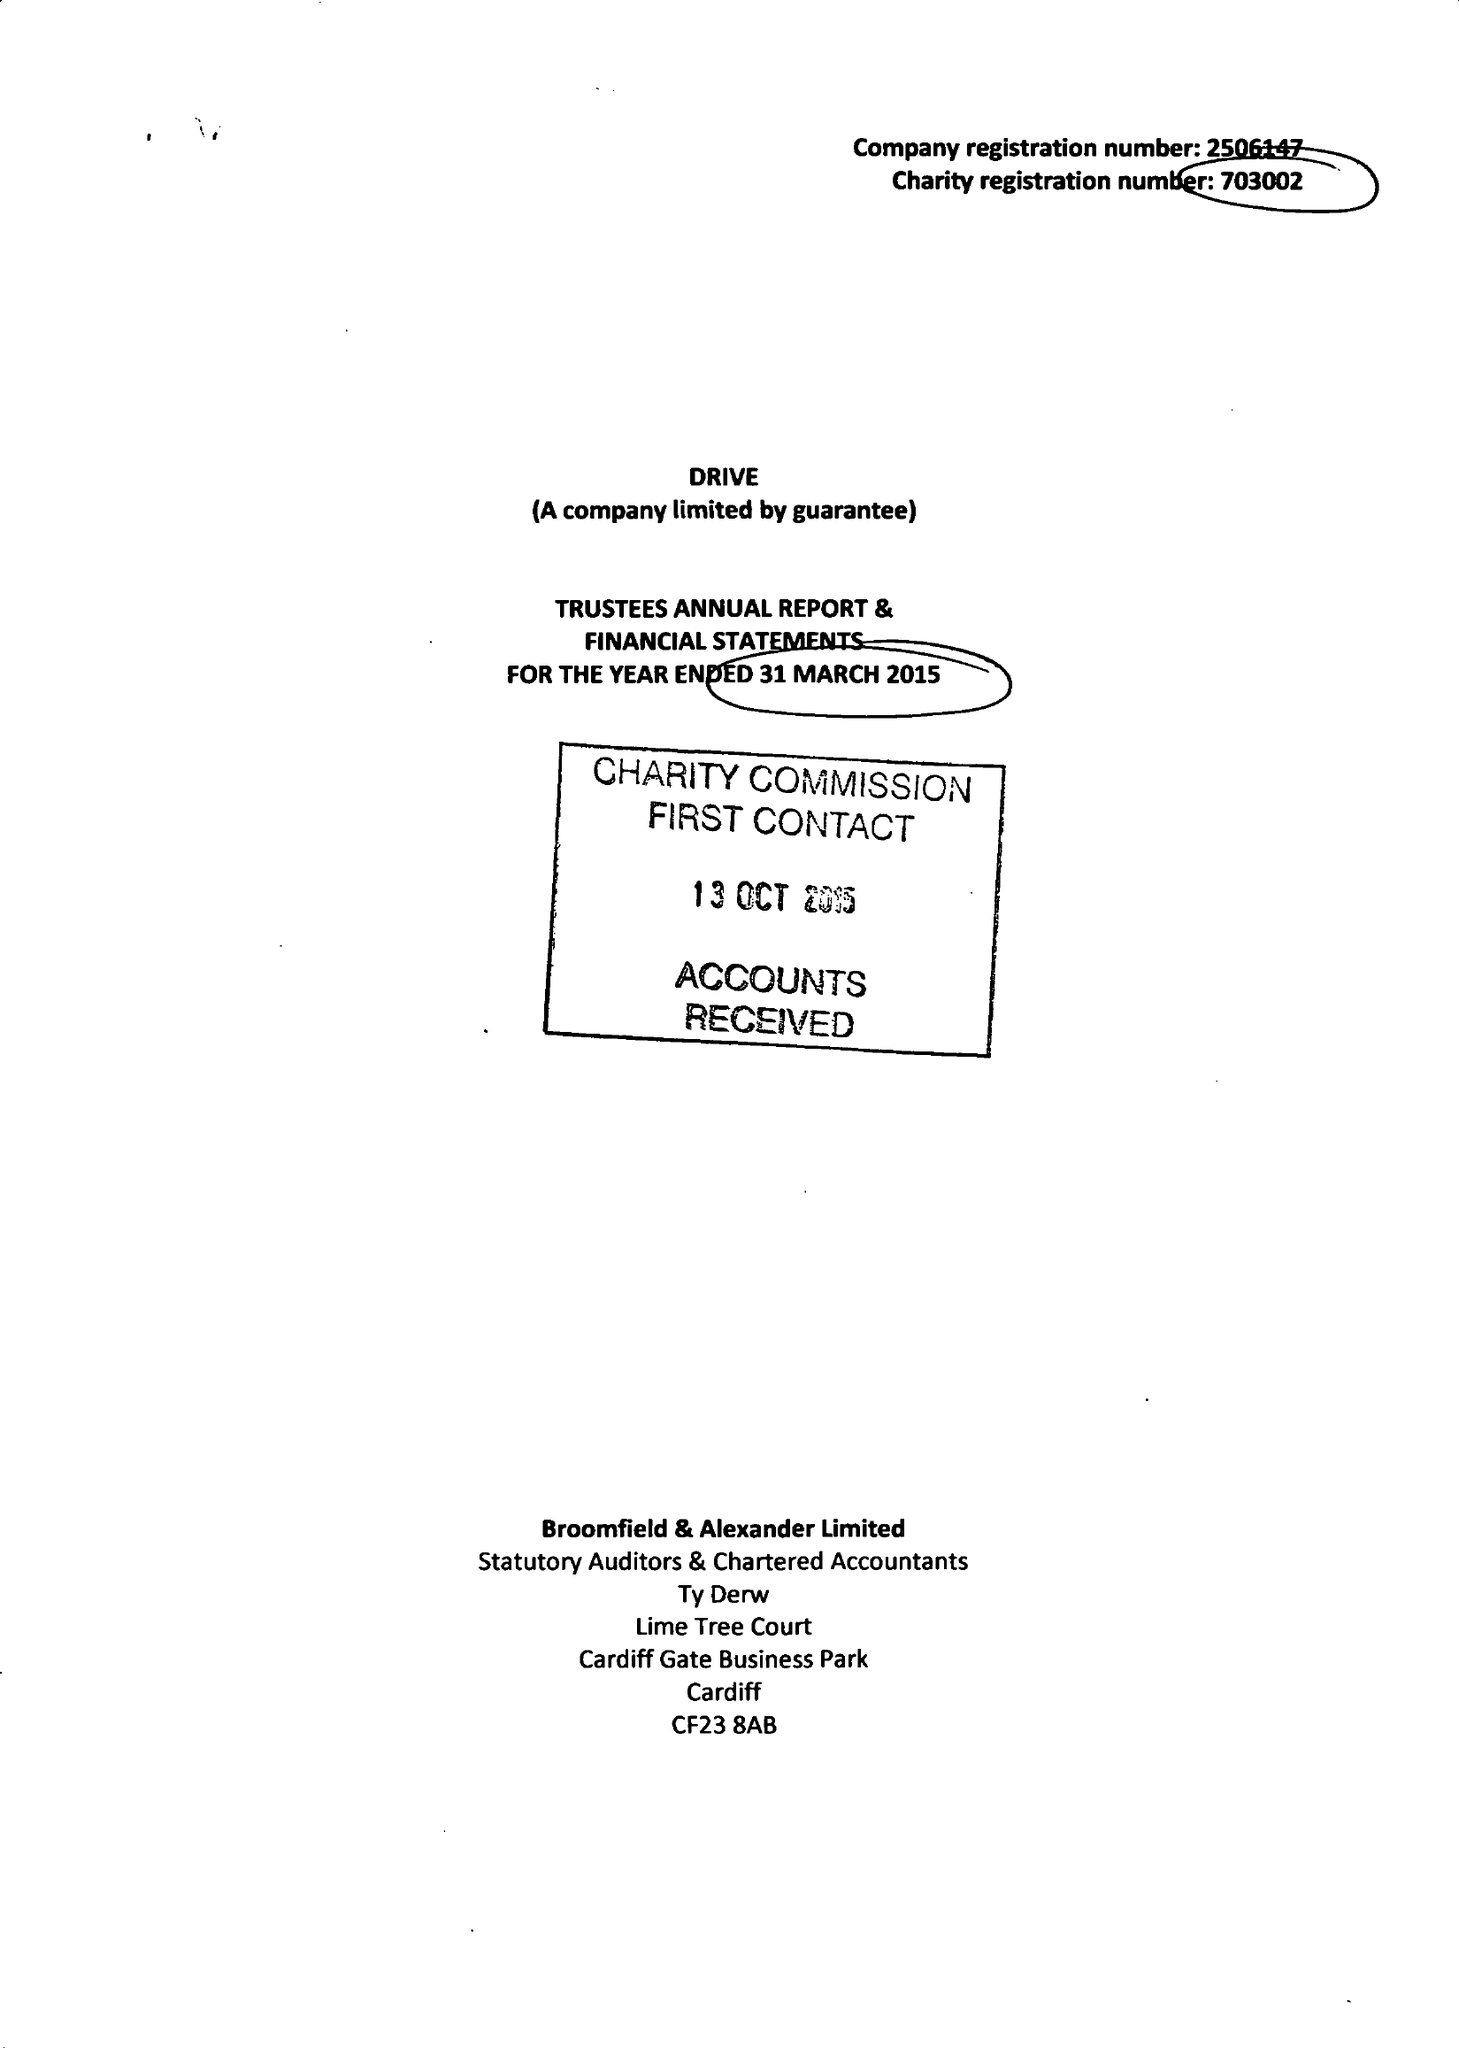What is the value for the charity_name?
Answer the question using a single word or phrase. Drive 